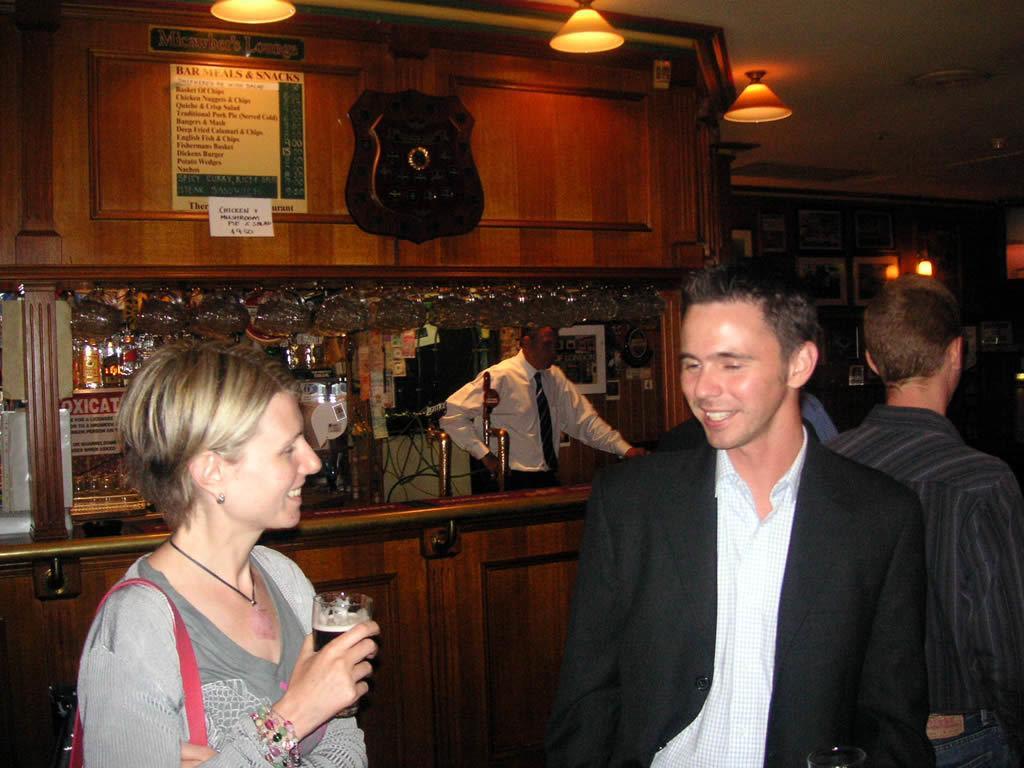Please provide a concise description of this image. In this picture we can see a woman holding a glass. There are few people. We can see some lights on top. There are few glasses, bottles and other things. We can see a board on a wooden object. There are few frames on the wall. 